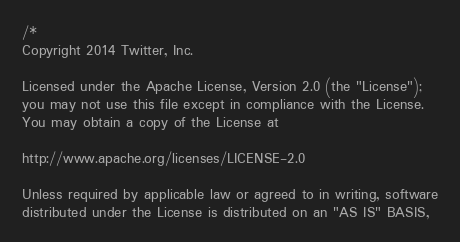Convert code to text. <code><loc_0><loc_0><loc_500><loc_500><_Scala_>/*
Copyright 2014 Twitter, Inc.

Licensed under the Apache License, Version 2.0 (the "License");
you may not use this file except in compliance with the License.
You may obtain a copy of the License at

http://www.apache.org/licenses/LICENSE-2.0

Unless required by applicable law or agreed to in writing, software
distributed under the License is distributed on an "AS IS" BASIS,</code> 